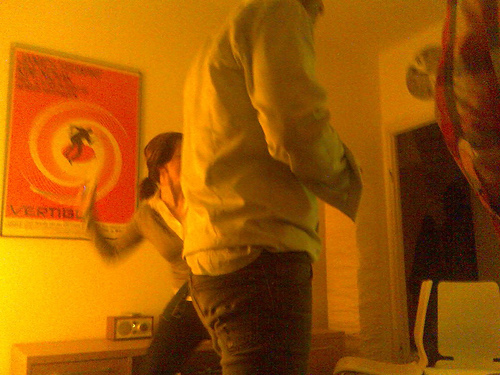Identify the text contained in this image. VERTIGL 